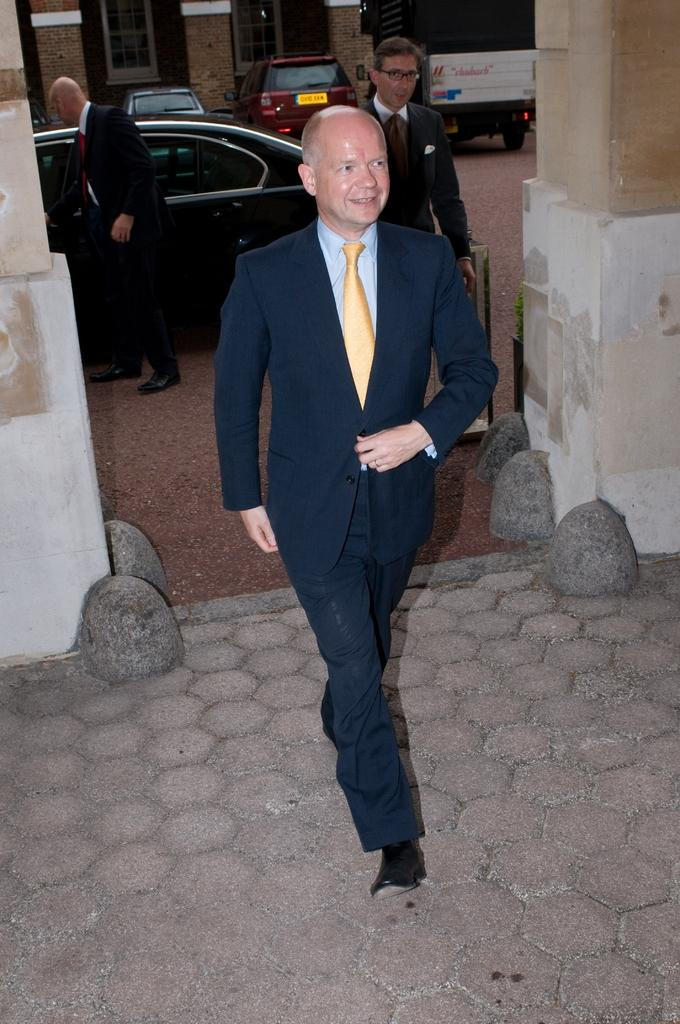What is the main action of the person in the image? There is a person walking in the image. What surface is the person walking on? The person is walking on the ground. What can be seen in the background of the image? There are cars, people, and buildings in the background of the image. What type of fiction is the person reading while walking in the image? There is no indication in the image that the person is reading any fiction; they are simply walking. 